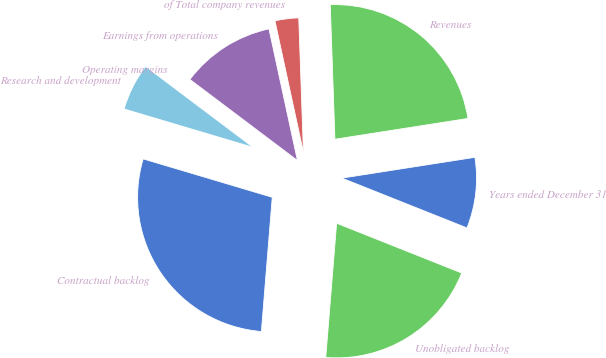Convert chart. <chart><loc_0><loc_0><loc_500><loc_500><pie_chart><fcel>Years ended December 31<fcel>Revenues<fcel>of Total company revenues<fcel>Earnings from operations<fcel>Operating margins<fcel>Research and development<fcel>Contractual backlog<fcel>Unobligated backlog<nl><fcel>8.5%<fcel>23.09%<fcel>2.84%<fcel>11.33%<fcel>0.01%<fcel>5.67%<fcel>28.32%<fcel>20.26%<nl></chart> 